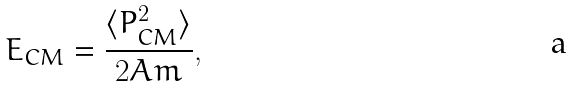<formula> <loc_0><loc_0><loc_500><loc_500>E _ { C M } = \frac { \langle P ^ { 2 } _ { C M } \rangle } { 2 A m } ,</formula> 